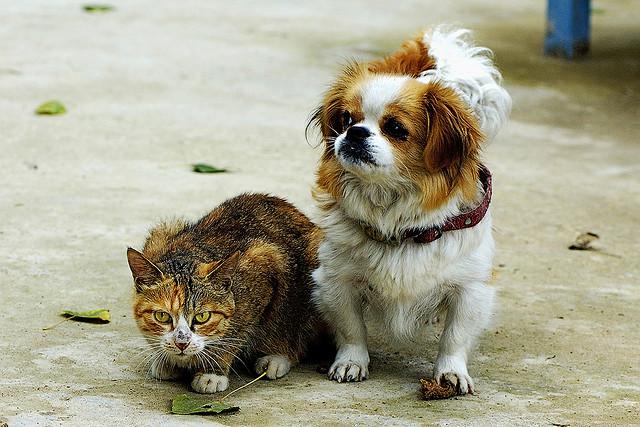What kind of animal is looking at the camera?
Give a very brief answer. Cat. Is the dog playing with a tangerine?
Concise answer only. No. What breed is this dog?
Answer briefly. Terrier. What breed of dog is this?
Concise answer only. Shih tzu. Is the collar too big?
Be succinct. Yes. How many animals?
Answer briefly. 2. Is the dog older or younger?
Short answer required. Younger. Are these animals clean?
Short answer required. No. 